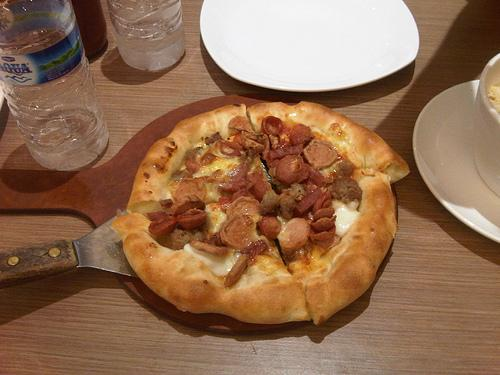What is under the food? Please explain your reasoning. spatula. The spatula is underneath. 